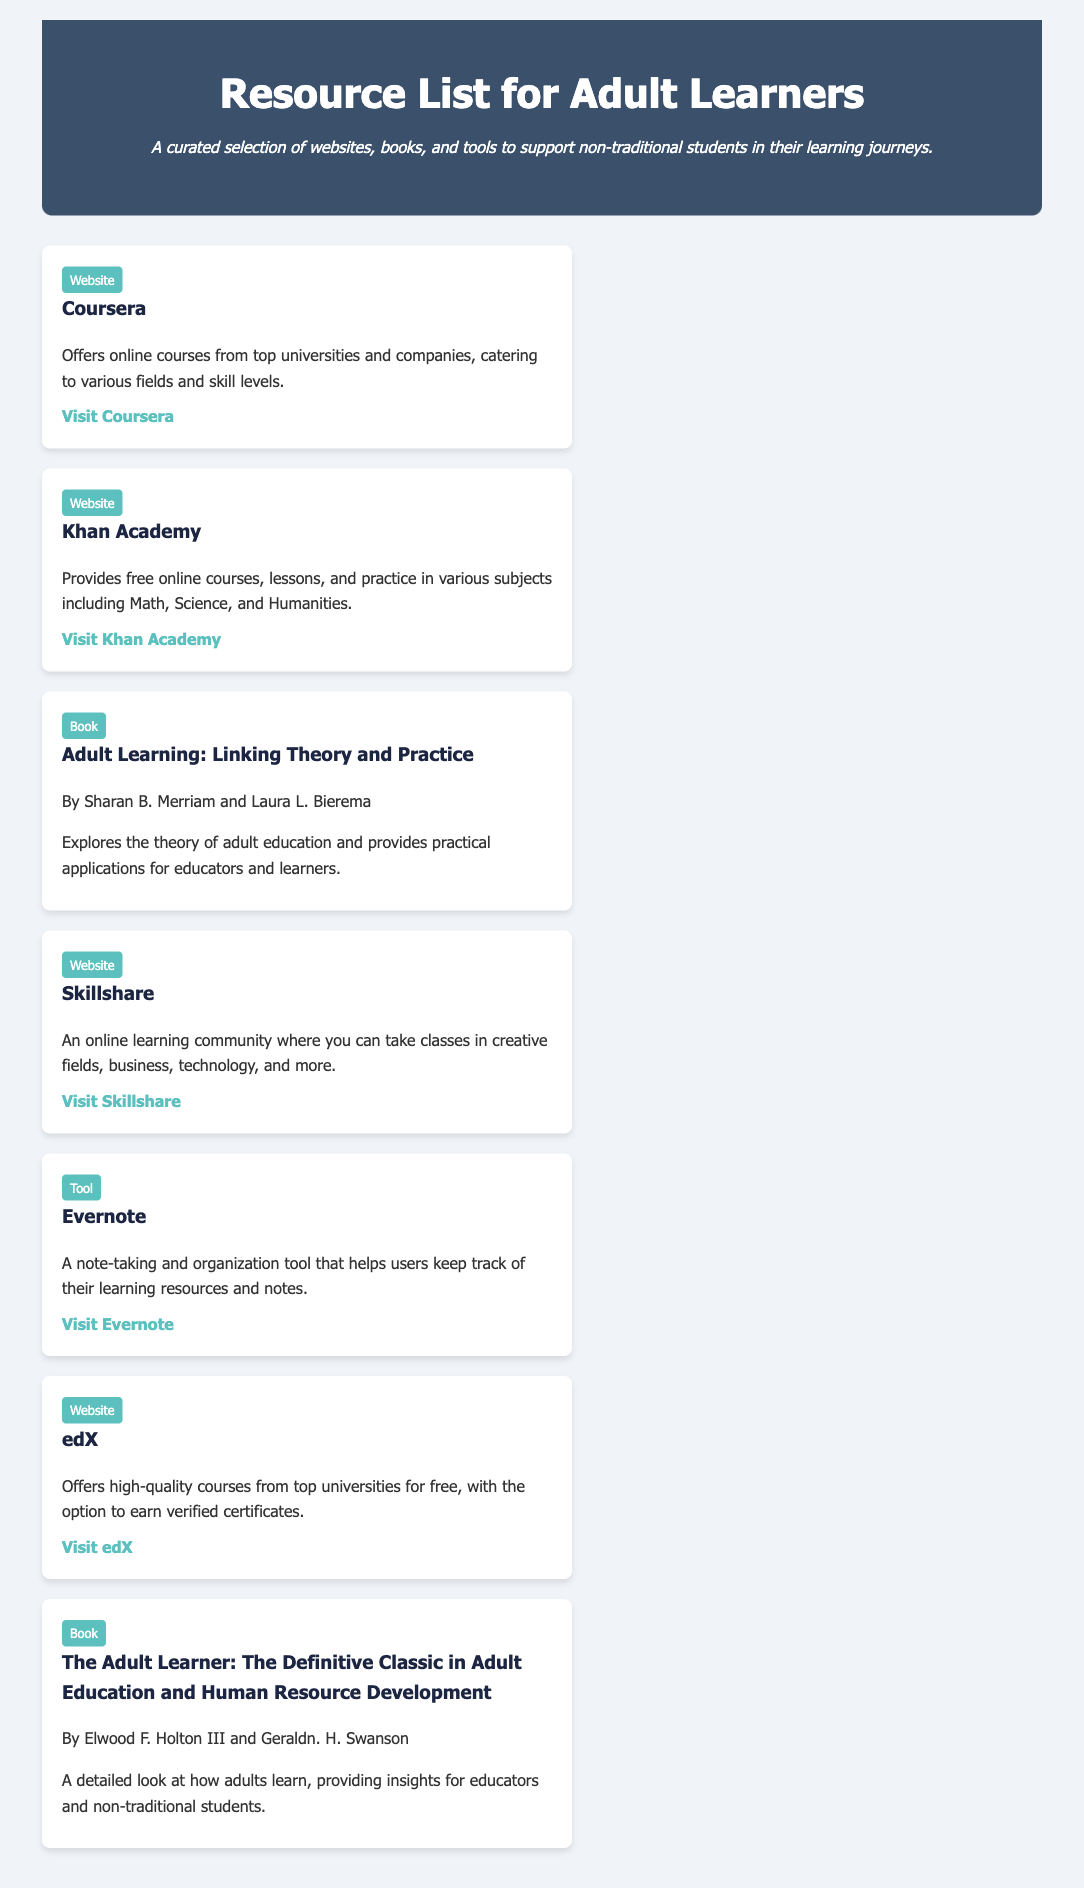What is the title of the document? The title of the document is stated in the header section of the document.
Answer: Resource List for Adult Learners Who authored the book "Adult Learning: Linking Theory and Practice"? The authors of the book are listed in the resource section dedicated to books.
Answer: Sharan B. Merriam and Laura L. Bierema What type of resource is Evernote? The type of resource is specified in the tags provided for each resource in the document.
Answer: Tool How many websites are listed in the document? To determine the count, one needs to count the resources tagged as "Website."
Answer: 4 What online community focuses on creative fields? The document provides names of various resources, including those focused on specific fields.
Answer: Skillshare Which resource offers courses from top universities for free? This is identified based on the description provided for the resources in the document.
Answer: edX What behavior is described for the resources when hovered over? The document includes a style description for the resources.
Answer: Transform: translateY(-5px) Name one of the books listed for adult learners. The titles of the books are mentioned in their respective sections within the document.
Answer: The Adult Learner: The Definitive Classic in Adult Education and Human Resource Development 